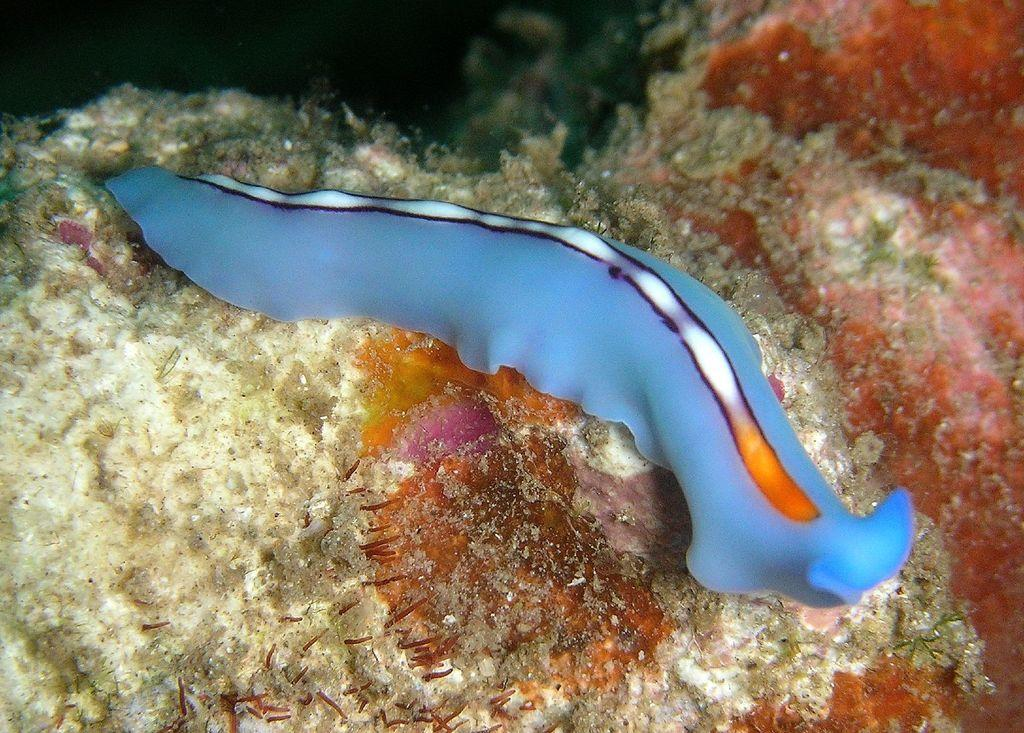What type of animal can be seen in the image? There is a blue aquatic animal in the image. What else is present in the image besides the animal? There are aquatic plants in the image. What type of shoes is the worm wearing in the image? There is no worm or shoes present in the image. 